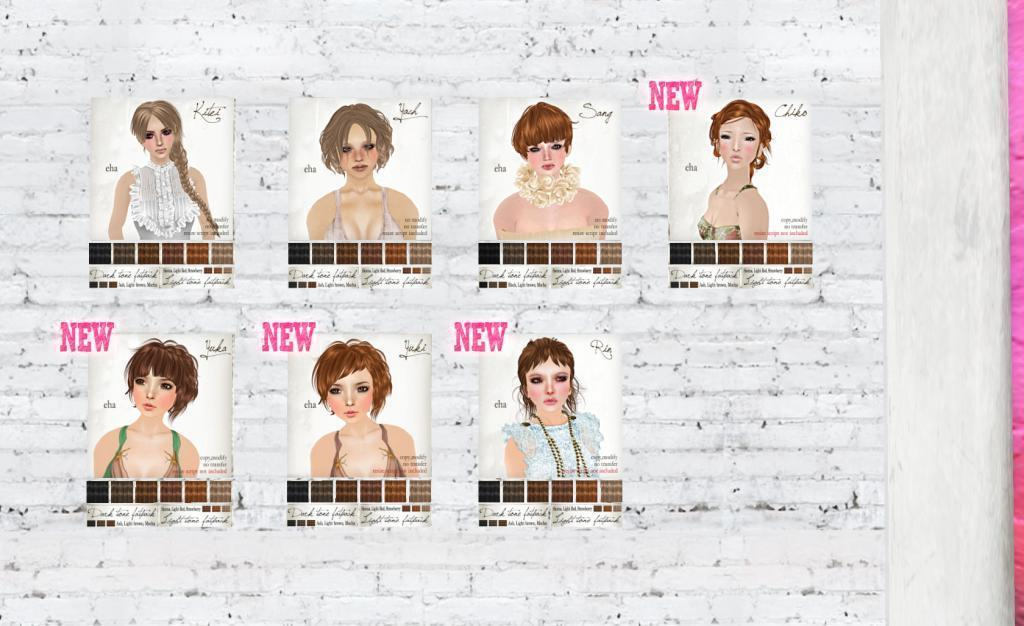How many posters are on the wall in the image? There are seven posters on the wall in the image. What can be seen on the right side of the image? There is a pillar on the right side of the image. What type of organization is depicted on the posters in the image? There is no information about the content of the posters in the image, so it is not possible to determine if they depict any organization. 